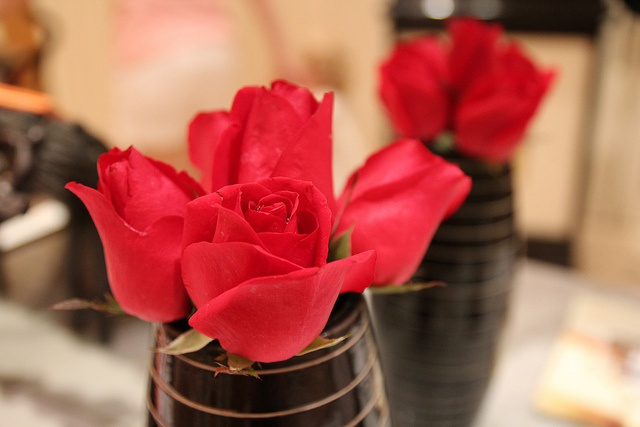Describe the objects in this image and their specific colors. I can see vase in salmon, black, and gray tones and vase in salmon, black, maroon, and gray tones in this image. 